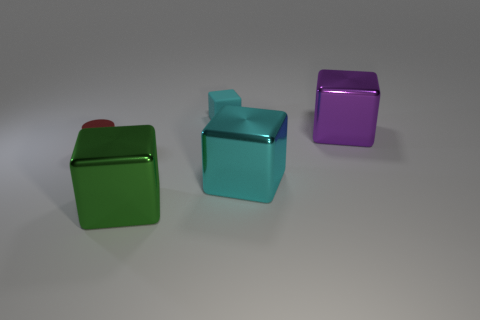What is the shape of the cyan thing that is in front of the cyan thing behind the metallic object that is behind the small cylinder?
Provide a short and direct response. Cube. What number of things are blocks that are in front of the small matte cube or small objects that are on the left side of the cyan matte block?
Give a very brief answer. 4. Are there any big green metallic objects behind the small cyan matte object?
Keep it short and to the point. No. How many things are large metallic things that are to the right of the tiny cyan cube or small cyan blocks?
Provide a short and direct response. 3. How many purple objects are either matte blocks or tiny shiny cylinders?
Make the answer very short. 0. What number of other things are there of the same color as the small cube?
Give a very brief answer. 1. Is the number of tiny matte things that are right of the tiny cyan object less than the number of cyan metallic blocks?
Offer a terse response. Yes. There is a big block that is behind the shiny thing on the left side of the large shiny thing that is in front of the large cyan shiny thing; what color is it?
Give a very brief answer. Purple. Are there any other things that have the same material as the red thing?
Offer a very short reply. Yes. There is a purple metal object that is the same shape as the matte thing; what size is it?
Your answer should be very brief. Large. 